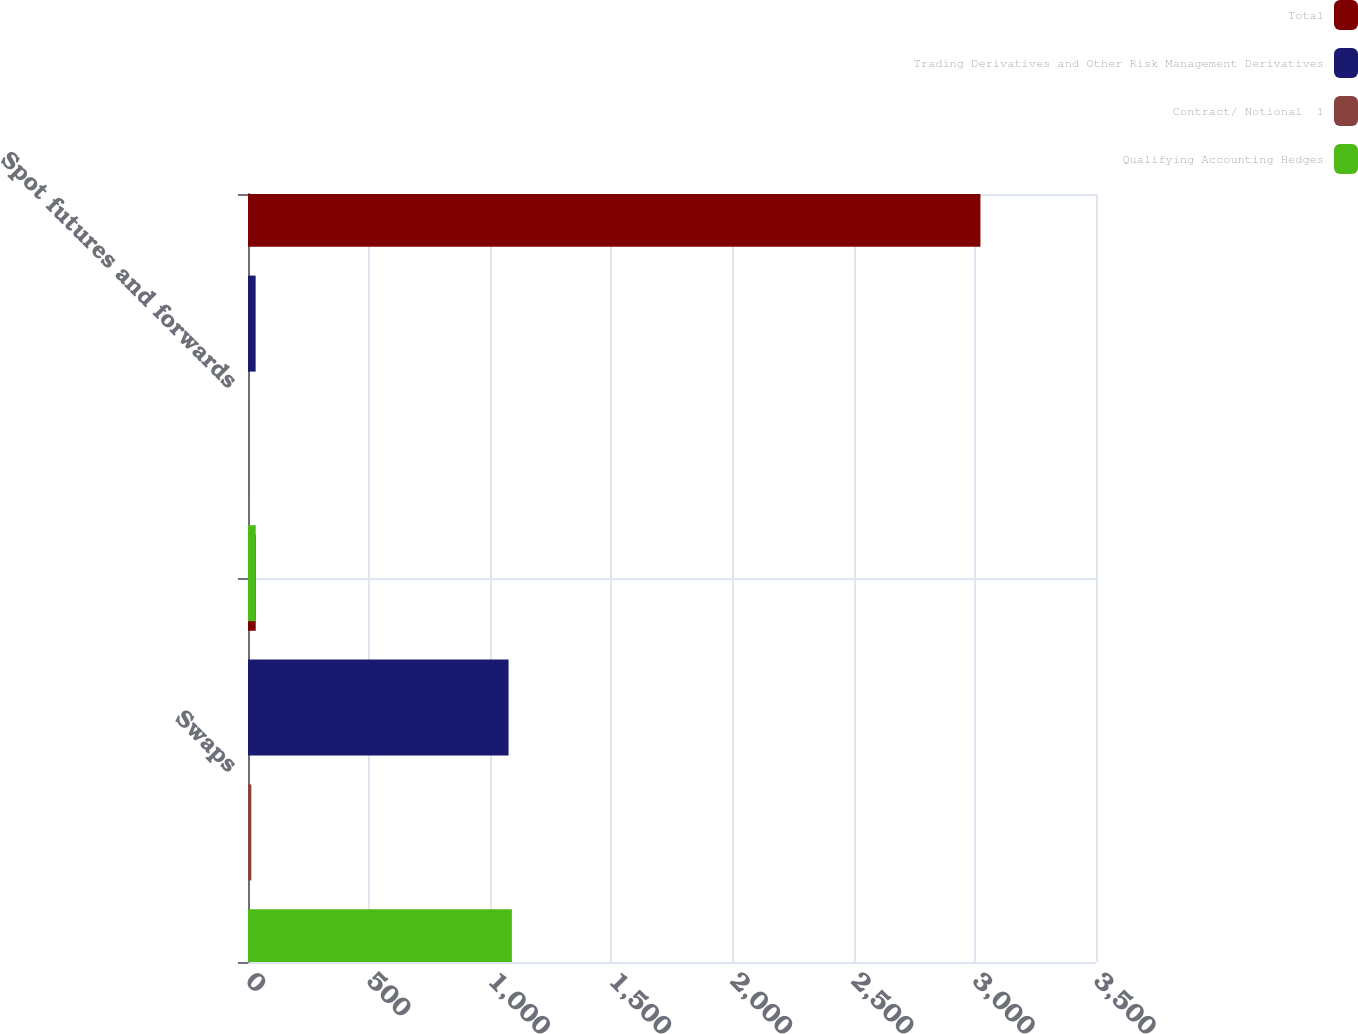Convert chart. <chart><loc_0><loc_0><loc_500><loc_500><stacked_bar_chart><ecel><fcel>Swaps<fcel>Spot futures and forwards<nl><fcel>Total<fcel>31.9<fcel>3023<nl><fcel>Trading Derivatives and Other Risk Management Derivatives<fcel>1075.4<fcel>31.5<nl><fcel>Contract/ Notional  1<fcel>13.8<fcel>0.4<nl><fcel>Qualifying Accounting Hedges<fcel>1089.2<fcel>31.9<nl></chart> 